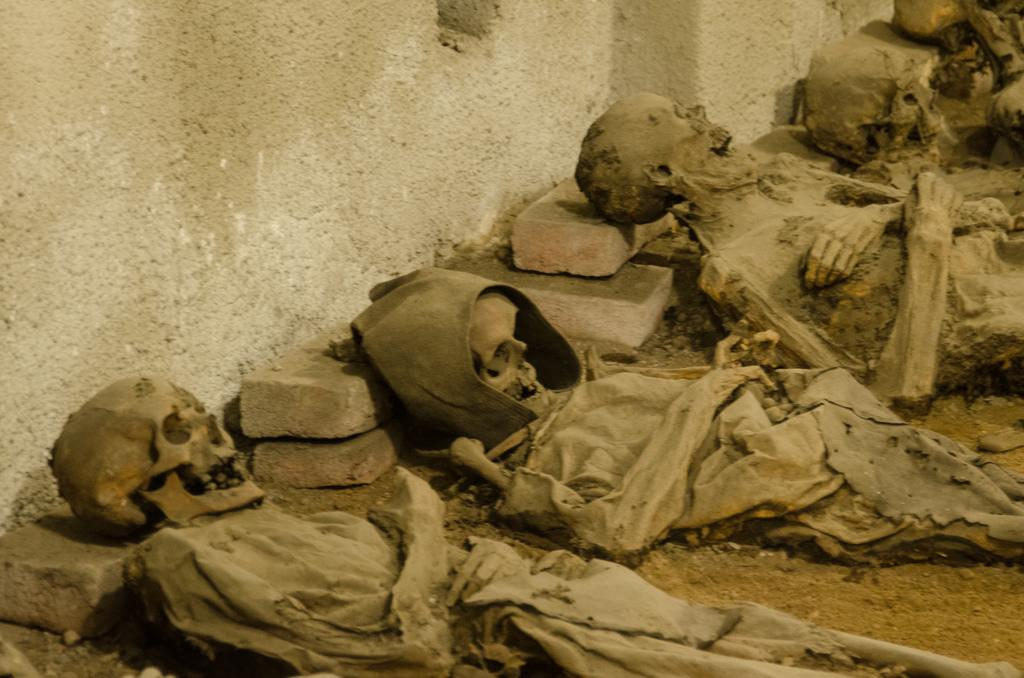What type of surface can be seen in the image? There is ground visible in the image. What is located on the ground in the image? There are skeletons on the ground. What is the color of the wall in the image? The wall in the image is white and cream in color. How many eyes can be seen on the nut in the image? There is no nut present in the image, and therefore no eyes can be seen on it. 